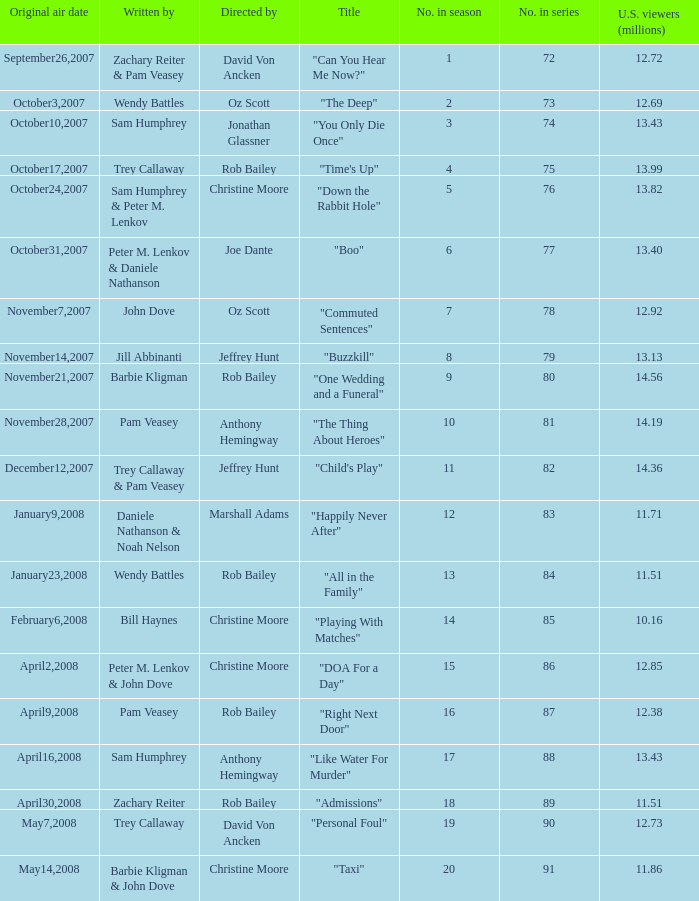Write the full table. {'header': ['Original air date', 'Written by', 'Directed by', 'Title', 'No. in season', 'No. in series', 'U.S. viewers (millions)'], 'rows': [['September26,2007', 'Zachary Reiter & Pam Veasey', 'David Von Ancken', '"Can You Hear Me Now?"', '1', '72', '12.72'], ['October3,2007', 'Wendy Battles', 'Oz Scott', '"The Deep"', '2', '73', '12.69'], ['October10,2007', 'Sam Humphrey', 'Jonathan Glassner', '"You Only Die Once"', '3', '74', '13.43'], ['October17,2007', 'Trey Callaway', 'Rob Bailey', '"Time\'s Up"', '4', '75', '13.99'], ['October24,2007', 'Sam Humphrey & Peter M. Lenkov', 'Christine Moore', '"Down the Rabbit Hole"', '5', '76', '13.82'], ['October31,2007', 'Peter M. Lenkov & Daniele Nathanson', 'Joe Dante', '"Boo"', '6', '77', '13.40'], ['November7,2007', 'John Dove', 'Oz Scott', '"Commuted Sentences"', '7', '78', '12.92'], ['November14,2007', 'Jill Abbinanti', 'Jeffrey Hunt', '"Buzzkill"', '8', '79', '13.13'], ['November21,2007', 'Barbie Kligman', 'Rob Bailey', '"One Wedding and a Funeral"', '9', '80', '14.56'], ['November28,2007', 'Pam Veasey', 'Anthony Hemingway', '"The Thing About Heroes"', '10', '81', '14.19'], ['December12,2007', 'Trey Callaway & Pam Veasey', 'Jeffrey Hunt', '"Child\'s Play"', '11', '82', '14.36'], ['January9,2008', 'Daniele Nathanson & Noah Nelson', 'Marshall Adams', '"Happily Never After"', '12', '83', '11.71'], ['January23,2008', 'Wendy Battles', 'Rob Bailey', '"All in the Family"', '13', '84', '11.51'], ['February6,2008', 'Bill Haynes', 'Christine Moore', '"Playing With Matches"', '14', '85', '10.16'], ['April2,2008', 'Peter M. Lenkov & John Dove', 'Christine Moore', '"DOA For a Day"', '15', '86', '12.85'], ['April9,2008', 'Pam Veasey', 'Rob Bailey', '"Right Next Door"', '16', '87', '12.38'], ['April16,2008', 'Sam Humphrey', 'Anthony Hemingway', '"Like Water For Murder"', '17', '88', '13.43'], ['April30,2008', 'Zachary Reiter', 'Rob Bailey', '"Admissions"', '18', '89', '11.51'], ['May7,2008', 'Trey Callaway', 'David Von Ancken', '"Personal Foul"', '19', '90', '12.73'], ['May14,2008', 'Barbie Kligman & John Dove', 'Christine Moore', '"Taxi"', '20', '91', '11.86']]} How many episodes were watched by 12.72 million U.S. viewers? 1.0. 